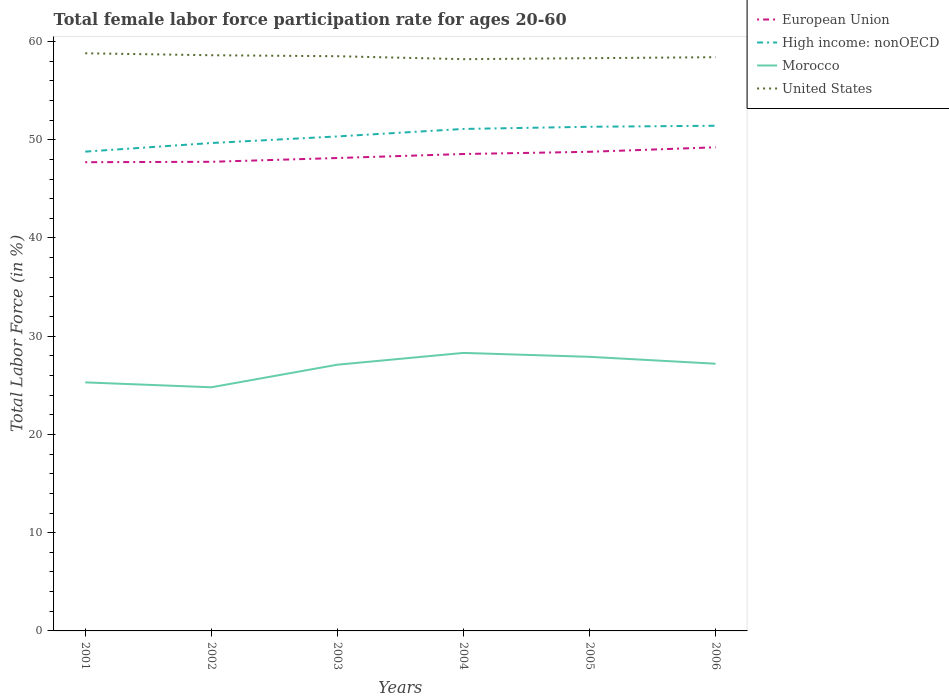How many different coloured lines are there?
Your answer should be very brief. 4. Does the line corresponding to United States intersect with the line corresponding to High income: nonOECD?
Your answer should be compact. No. Across all years, what is the maximum female labor force participation rate in United States?
Make the answer very short. 58.2. In which year was the female labor force participation rate in United States maximum?
Your answer should be very brief. 2004. What is the total female labor force participation rate in European Union in the graph?
Ensure brevity in your answer.  -0.79. What is the difference between the highest and the second highest female labor force participation rate in European Union?
Make the answer very short. 1.52. What is the difference between the highest and the lowest female labor force participation rate in United States?
Your response must be concise. 3. How many lines are there?
Make the answer very short. 4. What is the difference between two consecutive major ticks on the Y-axis?
Your response must be concise. 10. Are the values on the major ticks of Y-axis written in scientific E-notation?
Make the answer very short. No. Does the graph contain any zero values?
Keep it short and to the point. No. Where does the legend appear in the graph?
Ensure brevity in your answer.  Top right. What is the title of the graph?
Give a very brief answer. Total female labor force participation rate for ages 20-60. Does "High income: OECD" appear as one of the legend labels in the graph?
Keep it short and to the point. No. What is the label or title of the X-axis?
Offer a very short reply. Years. What is the label or title of the Y-axis?
Your response must be concise. Total Labor Force (in %). What is the Total Labor Force (in %) of European Union in 2001?
Keep it short and to the point. 47.71. What is the Total Labor Force (in %) of High income: nonOECD in 2001?
Offer a very short reply. 48.79. What is the Total Labor Force (in %) of Morocco in 2001?
Keep it short and to the point. 25.3. What is the Total Labor Force (in %) of United States in 2001?
Offer a terse response. 58.8. What is the Total Labor Force (in %) of European Union in 2002?
Give a very brief answer. 47.75. What is the Total Labor Force (in %) in High income: nonOECD in 2002?
Provide a short and direct response. 49.66. What is the Total Labor Force (in %) of Morocco in 2002?
Make the answer very short. 24.8. What is the Total Labor Force (in %) of United States in 2002?
Offer a very short reply. 58.6. What is the Total Labor Force (in %) of European Union in 2003?
Offer a very short reply. 48.14. What is the Total Labor Force (in %) in High income: nonOECD in 2003?
Provide a short and direct response. 50.34. What is the Total Labor Force (in %) in Morocco in 2003?
Offer a very short reply. 27.1. What is the Total Labor Force (in %) of United States in 2003?
Keep it short and to the point. 58.5. What is the Total Labor Force (in %) in European Union in 2004?
Offer a terse response. 48.55. What is the Total Labor Force (in %) in High income: nonOECD in 2004?
Make the answer very short. 51.1. What is the Total Labor Force (in %) in Morocco in 2004?
Offer a terse response. 28.3. What is the Total Labor Force (in %) in United States in 2004?
Keep it short and to the point. 58.2. What is the Total Labor Force (in %) in European Union in 2005?
Provide a succinct answer. 48.77. What is the Total Labor Force (in %) of High income: nonOECD in 2005?
Ensure brevity in your answer.  51.32. What is the Total Labor Force (in %) in Morocco in 2005?
Provide a short and direct response. 27.9. What is the Total Labor Force (in %) in United States in 2005?
Provide a succinct answer. 58.3. What is the Total Labor Force (in %) of European Union in 2006?
Offer a terse response. 49.23. What is the Total Labor Force (in %) of High income: nonOECD in 2006?
Provide a short and direct response. 51.42. What is the Total Labor Force (in %) in Morocco in 2006?
Your answer should be compact. 27.2. What is the Total Labor Force (in %) in United States in 2006?
Ensure brevity in your answer.  58.4. Across all years, what is the maximum Total Labor Force (in %) of European Union?
Ensure brevity in your answer.  49.23. Across all years, what is the maximum Total Labor Force (in %) of High income: nonOECD?
Ensure brevity in your answer.  51.42. Across all years, what is the maximum Total Labor Force (in %) of Morocco?
Your response must be concise. 28.3. Across all years, what is the maximum Total Labor Force (in %) in United States?
Make the answer very short. 58.8. Across all years, what is the minimum Total Labor Force (in %) in European Union?
Your answer should be very brief. 47.71. Across all years, what is the minimum Total Labor Force (in %) of High income: nonOECD?
Ensure brevity in your answer.  48.79. Across all years, what is the minimum Total Labor Force (in %) in Morocco?
Make the answer very short. 24.8. Across all years, what is the minimum Total Labor Force (in %) of United States?
Your answer should be compact. 58.2. What is the total Total Labor Force (in %) of European Union in the graph?
Offer a terse response. 290.15. What is the total Total Labor Force (in %) of High income: nonOECD in the graph?
Make the answer very short. 302.63. What is the total Total Labor Force (in %) of Morocco in the graph?
Provide a succinct answer. 160.6. What is the total Total Labor Force (in %) in United States in the graph?
Make the answer very short. 350.8. What is the difference between the Total Labor Force (in %) of European Union in 2001 and that in 2002?
Keep it short and to the point. -0.04. What is the difference between the Total Labor Force (in %) of High income: nonOECD in 2001 and that in 2002?
Offer a terse response. -0.87. What is the difference between the Total Labor Force (in %) in United States in 2001 and that in 2002?
Your answer should be compact. 0.2. What is the difference between the Total Labor Force (in %) in European Union in 2001 and that in 2003?
Keep it short and to the point. -0.43. What is the difference between the Total Labor Force (in %) in High income: nonOECD in 2001 and that in 2003?
Offer a very short reply. -1.55. What is the difference between the Total Labor Force (in %) in Morocco in 2001 and that in 2003?
Provide a succinct answer. -1.8. What is the difference between the Total Labor Force (in %) of United States in 2001 and that in 2003?
Your answer should be compact. 0.3. What is the difference between the Total Labor Force (in %) in European Union in 2001 and that in 2004?
Offer a terse response. -0.83. What is the difference between the Total Labor Force (in %) in High income: nonOECD in 2001 and that in 2004?
Offer a very short reply. -2.31. What is the difference between the Total Labor Force (in %) in United States in 2001 and that in 2004?
Offer a very short reply. 0.6. What is the difference between the Total Labor Force (in %) in European Union in 2001 and that in 2005?
Your answer should be very brief. -1.06. What is the difference between the Total Labor Force (in %) in High income: nonOECD in 2001 and that in 2005?
Ensure brevity in your answer.  -2.53. What is the difference between the Total Labor Force (in %) in Morocco in 2001 and that in 2005?
Make the answer very short. -2.6. What is the difference between the Total Labor Force (in %) of United States in 2001 and that in 2005?
Ensure brevity in your answer.  0.5. What is the difference between the Total Labor Force (in %) of European Union in 2001 and that in 2006?
Offer a very short reply. -1.52. What is the difference between the Total Labor Force (in %) of High income: nonOECD in 2001 and that in 2006?
Offer a very short reply. -2.63. What is the difference between the Total Labor Force (in %) in European Union in 2002 and that in 2003?
Give a very brief answer. -0.39. What is the difference between the Total Labor Force (in %) of High income: nonOECD in 2002 and that in 2003?
Provide a succinct answer. -0.67. What is the difference between the Total Labor Force (in %) of European Union in 2002 and that in 2004?
Your answer should be very brief. -0.79. What is the difference between the Total Labor Force (in %) of High income: nonOECD in 2002 and that in 2004?
Your answer should be compact. -1.43. What is the difference between the Total Labor Force (in %) in Morocco in 2002 and that in 2004?
Offer a very short reply. -3.5. What is the difference between the Total Labor Force (in %) in European Union in 2002 and that in 2005?
Keep it short and to the point. -1.02. What is the difference between the Total Labor Force (in %) in High income: nonOECD in 2002 and that in 2005?
Provide a succinct answer. -1.66. What is the difference between the Total Labor Force (in %) in United States in 2002 and that in 2005?
Your answer should be compact. 0.3. What is the difference between the Total Labor Force (in %) in European Union in 2002 and that in 2006?
Offer a terse response. -1.48. What is the difference between the Total Labor Force (in %) in High income: nonOECD in 2002 and that in 2006?
Your response must be concise. -1.76. What is the difference between the Total Labor Force (in %) of European Union in 2003 and that in 2004?
Provide a succinct answer. -0.41. What is the difference between the Total Labor Force (in %) in High income: nonOECD in 2003 and that in 2004?
Make the answer very short. -0.76. What is the difference between the Total Labor Force (in %) of Morocco in 2003 and that in 2004?
Provide a short and direct response. -1.2. What is the difference between the Total Labor Force (in %) in European Union in 2003 and that in 2005?
Make the answer very short. -0.63. What is the difference between the Total Labor Force (in %) of High income: nonOECD in 2003 and that in 2005?
Offer a very short reply. -0.98. What is the difference between the Total Labor Force (in %) in United States in 2003 and that in 2005?
Provide a succinct answer. 0.2. What is the difference between the Total Labor Force (in %) of European Union in 2003 and that in 2006?
Give a very brief answer. -1.09. What is the difference between the Total Labor Force (in %) in High income: nonOECD in 2003 and that in 2006?
Your answer should be compact. -1.09. What is the difference between the Total Labor Force (in %) of United States in 2003 and that in 2006?
Provide a short and direct response. 0.1. What is the difference between the Total Labor Force (in %) in European Union in 2004 and that in 2005?
Ensure brevity in your answer.  -0.22. What is the difference between the Total Labor Force (in %) of High income: nonOECD in 2004 and that in 2005?
Provide a short and direct response. -0.22. What is the difference between the Total Labor Force (in %) of Morocco in 2004 and that in 2005?
Make the answer very short. 0.4. What is the difference between the Total Labor Force (in %) of European Union in 2004 and that in 2006?
Your answer should be very brief. -0.68. What is the difference between the Total Labor Force (in %) in High income: nonOECD in 2004 and that in 2006?
Your answer should be compact. -0.33. What is the difference between the Total Labor Force (in %) of United States in 2004 and that in 2006?
Your answer should be very brief. -0.2. What is the difference between the Total Labor Force (in %) of European Union in 2005 and that in 2006?
Provide a short and direct response. -0.46. What is the difference between the Total Labor Force (in %) in High income: nonOECD in 2005 and that in 2006?
Offer a terse response. -0.1. What is the difference between the Total Labor Force (in %) in United States in 2005 and that in 2006?
Your response must be concise. -0.1. What is the difference between the Total Labor Force (in %) of European Union in 2001 and the Total Labor Force (in %) of High income: nonOECD in 2002?
Your answer should be compact. -1.95. What is the difference between the Total Labor Force (in %) of European Union in 2001 and the Total Labor Force (in %) of Morocco in 2002?
Make the answer very short. 22.91. What is the difference between the Total Labor Force (in %) in European Union in 2001 and the Total Labor Force (in %) in United States in 2002?
Your answer should be very brief. -10.89. What is the difference between the Total Labor Force (in %) in High income: nonOECD in 2001 and the Total Labor Force (in %) in Morocco in 2002?
Ensure brevity in your answer.  23.99. What is the difference between the Total Labor Force (in %) of High income: nonOECD in 2001 and the Total Labor Force (in %) of United States in 2002?
Provide a short and direct response. -9.81. What is the difference between the Total Labor Force (in %) in Morocco in 2001 and the Total Labor Force (in %) in United States in 2002?
Your answer should be very brief. -33.3. What is the difference between the Total Labor Force (in %) of European Union in 2001 and the Total Labor Force (in %) of High income: nonOECD in 2003?
Provide a succinct answer. -2.62. What is the difference between the Total Labor Force (in %) of European Union in 2001 and the Total Labor Force (in %) of Morocco in 2003?
Keep it short and to the point. 20.61. What is the difference between the Total Labor Force (in %) in European Union in 2001 and the Total Labor Force (in %) in United States in 2003?
Make the answer very short. -10.79. What is the difference between the Total Labor Force (in %) in High income: nonOECD in 2001 and the Total Labor Force (in %) in Morocco in 2003?
Offer a very short reply. 21.69. What is the difference between the Total Labor Force (in %) in High income: nonOECD in 2001 and the Total Labor Force (in %) in United States in 2003?
Keep it short and to the point. -9.71. What is the difference between the Total Labor Force (in %) of Morocco in 2001 and the Total Labor Force (in %) of United States in 2003?
Provide a succinct answer. -33.2. What is the difference between the Total Labor Force (in %) in European Union in 2001 and the Total Labor Force (in %) in High income: nonOECD in 2004?
Provide a succinct answer. -3.39. What is the difference between the Total Labor Force (in %) in European Union in 2001 and the Total Labor Force (in %) in Morocco in 2004?
Offer a very short reply. 19.41. What is the difference between the Total Labor Force (in %) of European Union in 2001 and the Total Labor Force (in %) of United States in 2004?
Provide a succinct answer. -10.49. What is the difference between the Total Labor Force (in %) in High income: nonOECD in 2001 and the Total Labor Force (in %) in Morocco in 2004?
Provide a succinct answer. 20.49. What is the difference between the Total Labor Force (in %) of High income: nonOECD in 2001 and the Total Labor Force (in %) of United States in 2004?
Give a very brief answer. -9.41. What is the difference between the Total Labor Force (in %) of Morocco in 2001 and the Total Labor Force (in %) of United States in 2004?
Your answer should be very brief. -32.9. What is the difference between the Total Labor Force (in %) in European Union in 2001 and the Total Labor Force (in %) in High income: nonOECD in 2005?
Your answer should be very brief. -3.61. What is the difference between the Total Labor Force (in %) of European Union in 2001 and the Total Labor Force (in %) of Morocco in 2005?
Your response must be concise. 19.81. What is the difference between the Total Labor Force (in %) of European Union in 2001 and the Total Labor Force (in %) of United States in 2005?
Provide a succinct answer. -10.59. What is the difference between the Total Labor Force (in %) of High income: nonOECD in 2001 and the Total Labor Force (in %) of Morocco in 2005?
Your answer should be very brief. 20.89. What is the difference between the Total Labor Force (in %) in High income: nonOECD in 2001 and the Total Labor Force (in %) in United States in 2005?
Keep it short and to the point. -9.51. What is the difference between the Total Labor Force (in %) of Morocco in 2001 and the Total Labor Force (in %) of United States in 2005?
Your response must be concise. -33. What is the difference between the Total Labor Force (in %) in European Union in 2001 and the Total Labor Force (in %) in High income: nonOECD in 2006?
Give a very brief answer. -3.71. What is the difference between the Total Labor Force (in %) of European Union in 2001 and the Total Labor Force (in %) of Morocco in 2006?
Your answer should be compact. 20.51. What is the difference between the Total Labor Force (in %) in European Union in 2001 and the Total Labor Force (in %) in United States in 2006?
Give a very brief answer. -10.69. What is the difference between the Total Labor Force (in %) in High income: nonOECD in 2001 and the Total Labor Force (in %) in Morocco in 2006?
Provide a succinct answer. 21.59. What is the difference between the Total Labor Force (in %) in High income: nonOECD in 2001 and the Total Labor Force (in %) in United States in 2006?
Make the answer very short. -9.61. What is the difference between the Total Labor Force (in %) of Morocco in 2001 and the Total Labor Force (in %) of United States in 2006?
Provide a succinct answer. -33.1. What is the difference between the Total Labor Force (in %) in European Union in 2002 and the Total Labor Force (in %) in High income: nonOECD in 2003?
Provide a succinct answer. -2.58. What is the difference between the Total Labor Force (in %) of European Union in 2002 and the Total Labor Force (in %) of Morocco in 2003?
Your response must be concise. 20.65. What is the difference between the Total Labor Force (in %) in European Union in 2002 and the Total Labor Force (in %) in United States in 2003?
Give a very brief answer. -10.75. What is the difference between the Total Labor Force (in %) in High income: nonOECD in 2002 and the Total Labor Force (in %) in Morocco in 2003?
Give a very brief answer. 22.56. What is the difference between the Total Labor Force (in %) in High income: nonOECD in 2002 and the Total Labor Force (in %) in United States in 2003?
Make the answer very short. -8.84. What is the difference between the Total Labor Force (in %) of Morocco in 2002 and the Total Labor Force (in %) of United States in 2003?
Provide a succinct answer. -33.7. What is the difference between the Total Labor Force (in %) of European Union in 2002 and the Total Labor Force (in %) of High income: nonOECD in 2004?
Give a very brief answer. -3.34. What is the difference between the Total Labor Force (in %) of European Union in 2002 and the Total Labor Force (in %) of Morocco in 2004?
Your answer should be compact. 19.45. What is the difference between the Total Labor Force (in %) in European Union in 2002 and the Total Labor Force (in %) in United States in 2004?
Provide a short and direct response. -10.45. What is the difference between the Total Labor Force (in %) in High income: nonOECD in 2002 and the Total Labor Force (in %) in Morocco in 2004?
Your response must be concise. 21.36. What is the difference between the Total Labor Force (in %) in High income: nonOECD in 2002 and the Total Labor Force (in %) in United States in 2004?
Offer a terse response. -8.54. What is the difference between the Total Labor Force (in %) in Morocco in 2002 and the Total Labor Force (in %) in United States in 2004?
Keep it short and to the point. -33.4. What is the difference between the Total Labor Force (in %) of European Union in 2002 and the Total Labor Force (in %) of High income: nonOECD in 2005?
Your answer should be compact. -3.57. What is the difference between the Total Labor Force (in %) in European Union in 2002 and the Total Labor Force (in %) in Morocco in 2005?
Your answer should be compact. 19.85. What is the difference between the Total Labor Force (in %) of European Union in 2002 and the Total Labor Force (in %) of United States in 2005?
Make the answer very short. -10.55. What is the difference between the Total Labor Force (in %) in High income: nonOECD in 2002 and the Total Labor Force (in %) in Morocco in 2005?
Ensure brevity in your answer.  21.76. What is the difference between the Total Labor Force (in %) of High income: nonOECD in 2002 and the Total Labor Force (in %) of United States in 2005?
Offer a terse response. -8.64. What is the difference between the Total Labor Force (in %) of Morocco in 2002 and the Total Labor Force (in %) of United States in 2005?
Give a very brief answer. -33.5. What is the difference between the Total Labor Force (in %) in European Union in 2002 and the Total Labor Force (in %) in High income: nonOECD in 2006?
Your response must be concise. -3.67. What is the difference between the Total Labor Force (in %) of European Union in 2002 and the Total Labor Force (in %) of Morocco in 2006?
Your response must be concise. 20.55. What is the difference between the Total Labor Force (in %) of European Union in 2002 and the Total Labor Force (in %) of United States in 2006?
Your answer should be compact. -10.65. What is the difference between the Total Labor Force (in %) of High income: nonOECD in 2002 and the Total Labor Force (in %) of Morocco in 2006?
Offer a terse response. 22.46. What is the difference between the Total Labor Force (in %) of High income: nonOECD in 2002 and the Total Labor Force (in %) of United States in 2006?
Your answer should be compact. -8.74. What is the difference between the Total Labor Force (in %) in Morocco in 2002 and the Total Labor Force (in %) in United States in 2006?
Offer a terse response. -33.6. What is the difference between the Total Labor Force (in %) of European Union in 2003 and the Total Labor Force (in %) of High income: nonOECD in 2004?
Your answer should be very brief. -2.96. What is the difference between the Total Labor Force (in %) of European Union in 2003 and the Total Labor Force (in %) of Morocco in 2004?
Keep it short and to the point. 19.84. What is the difference between the Total Labor Force (in %) in European Union in 2003 and the Total Labor Force (in %) in United States in 2004?
Make the answer very short. -10.06. What is the difference between the Total Labor Force (in %) of High income: nonOECD in 2003 and the Total Labor Force (in %) of Morocco in 2004?
Keep it short and to the point. 22.04. What is the difference between the Total Labor Force (in %) in High income: nonOECD in 2003 and the Total Labor Force (in %) in United States in 2004?
Offer a very short reply. -7.86. What is the difference between the Total Labor Force (in %) in Morocco in 2003 and the Total Labor Force (in %) in United States in 2004?
Ensure brevity in your answer.  -31.1. What is the difference between the Total Labor Force (in %) of European Union in 2003 and the Total Labor Force (in %) of High income: nonOECD in 2005?
Provide a succinct answer. -3.18. What is the difference between the Total Labor Force (in %) of European Union in 2003 and the Total Labor Force (in %) of Morocco in 2005?
Your response must be concise. 20.24. What is the difference between the Total Labor Force (in %) of European Union in 2003 and the Total Labor Force (in %) of United States in 2005?
Provide a succinct answer. -10.16. What is the difference between the Total Labor Force (in %) of High income: nonOECD in 2003 and the Total Labor Force (in %) of Morocco in 2005?
Make the answer very short. 22.44. What is the difference between the Total Labor Force (in %) in High income: nonOECD in 2003 and the Total Labor Force (in %) in United States in 2005?
Give a very brief answer. -7.96. What is the difference between the Total Labor Force (in %) of Morocco in 2003 and the Total Labor Force (in %) of United States in 2005?
Make the answer very short. -31.2. What is the difference between the Total Labor Force (in %) of European Union in 2003 and the Total Labor Force (in %) of High income: nonOECD in 2006?
Give a very brief answer. -3.29. What is the difference between the Total Labor Force (in %) of European Union in 2003 and the Total Labor Force (in %) of Morocco in 2006?
Ensure brevity in your answer.  20.94. What is the difference between the Total Labor Force (in %) of European Union in 2003 and the Total Labor Force (in %) of United States in 2006?
Your answer should be compact. -10.26. What is the difference between the Total Labor Force (in %) in High income: nonOECD in 2003 and the Total Labor Force (in %) in Morocco in 2006?
Offer a terse response. 23.14. What is the difference between the Total Labor Force (in %) of High income: nonOECD in 2003 and the Total Labor Force (in %) of United States in 2006?
Your answer should be very brief. -8.06. What is the difference between the Total Labor Force (in %) of Morocco in 2003 and the Total Labor Force (in %) of United States in 2006?
Give a very brief answer. -31.3. What is the difference between the Total Labor Force (in %) in European Union in 2004 and the Total Labor Force (in %) in High income: nonOECD in 2005?
Ensure brevity in your answer.  -2.77. What is the difference between the Total Labor Force (in %) in European Union in 2004 and the Total Labor Force (in %) in Morocco in 2005?
Make the answer very short. 20.65. What is the difference between the Total Labor Force (in %) of European Union in 2004 and the Total Labor Force (in %) of United States in 2005?
Provide a succinct answer. -9.75. What is the difference between the Total Labor Force (in %) in High income: nonOECD in 2004 and the Total Labor Force (in %) in Morocco in 2005?
Your answer should be compact. 23.2. What is the difference between the Total Labor Force (in %) of High income: nonOECD in 2004 and the Total Labor Force (in %) of United States in 2005?
Ensure brevity in your answer.  -7.2. What is the difference between the Total Labor Force (in %) in European Union in 2004 and the Total Labor Force (in %) in High income: nonOECD in 2006?
Your response must be concise. -2.88. What is the difference between the Total Labor Force (in %) of European Union in 2004 and the Total Labor Force (in %) of Morocco in 2006?
Provide a succinct answer. 21.35. What is the difference between the Total Labor Force (in %) of European Union in 2004 and the Total Labor Force (in %) of United States in 2006?
Your response must be concise. -9.85. What is the difference between the Total Labor Force (in %) of High income: nonOECD in 2004 and the Total Labor Force (in %) of Morocco in 2006?
Offer a very short reply. 23.9. What is the difference between the Total Labor Force (in %) in High income: nonOECD in 2004 and the Total Labor Force (in %) in United States in 2006?
Provide a short and direct response. -7.3. What is the difference between the Total Labor Force (in %) in Morocco in 2004 and the Total Labor Force (in %) in United States in 2006?
Make the answer very short. -30.1. What is the difference between the Total Labor Force (in %) of European Union in 2005 and the Total Labor Force (in %) of High income: nonOECD in 2006?
Your answer should be very brief. -2.65. What is the difference between the Total Labor Force (in %) of European Union in 2005 and the Total Labor Force (in %) of Morocco in 2006?
Make the answer very short. 21.57. What is the difference between the Total Labor Force (in %) in European Union in 2005 and the Total Labor Force (in %) in United States in 2006?
Provide a succinct answer. -9.63. What is the difference between the Total Labor Force (in %) in High income: nonOECD in 2005 and the Total Labor Force (in %) in Morocco in 2006?
Your answer should be compact. 24.12. What is the difference between the Total Labor Force (in %) in High income: nonOECD in 2005 and the Total Labor Force (in %) in United States in 2006?
Provide a succinct answer. -7.08. What is the difference between the Total Labor Force (in %) of Morocco in 2005 and the Total Labor Force (in %) of United States in 2006?
Make the answer very short. -30.5. What is the average Total Labor Force (in %) of European Union per year?
Offer a terse response. 48.36. What is the average Total Labor Force (in %) of High income: nonOECD per year?
Your answer should be compact. 50.44. What is the average Total Labor Force (in %) of Morocco per year?
Keep it short and to the point. 26.77. What is the average Total Labor Force (in %) in United States per year?
Offer a very short reply. 58.47. In the year 2001, what is the difference between the Total Labor Force (in %) of European Union and Total Labor Force (in %) of High income: nonOECD?
Give a very brief answer. -1.08. In the year 2001, what is the difference between the Total Labor Force (in %) in European Union and Total Labor Force (in %) in Morocco?
Offer a very short reply. 22.41. In the year 2001, what is the difference between the Total Labor Force (in %) in European Union and Total Labor Force (in %) in United States?
Offer a very short reply. -11.09. In the year 2001, what is the difference between the Total Labor Force (in %) of High income: nonOECD and Total Labor Force (in %) of Morocco?
Your answer should be compact. 23.49. In the year 2001, what is the difference between the Total Labor Force (in %) of High income: nonOECD and Total Labor Force (in %) of United States?
Give a very brief answer. -10.01. In the year 2001, what is the difference between the Total Labor Force (in %) of Morocco and Total Labor Force (in %) of United States?
Provide a succinct answer. -33.5. In the year 2002, what is the difference between the Total Labor Force (in %) of European Union and Total Labor Force (in %) of High income: nonOECD?
Keep it short and to the point. -1.91. In the year 2002, what is the difference between the Total Labor Force (in %) of European Union and Total Labor Force (in %) of Morocco?
Offer a terse response. 22.95. In the year 2002, what is the difference between the Total Labor Force (in %) of European Union and Total Labor Force (in %) of United States?
Ensure brevity in your answer.  -10.85. In the year 2002, what is the difference between the Total Labor Force (in %) in High income: nonOECD and Total Labor Force (in %) in Morocco?
Offer a very short reply. 24.86. In the year 2002, what is the difference between the Total Labor Force (in %) in High income: nonOECD and Total Labor Force (in %) in United States?
Keep it short and to the point. -8.94. In the year 2002, what is the difference between the Total Labor Force (in %) of Morocco and Total Labor Force (in %) of United States?
Give a very brief answer. -33.8. In the year 2003, what is the difference between the Total Labor Force (in %) in European Union and Total Labor Force (in %) in High income: nonOECD?
Your answer should be very brief. -2.2. In the year 2003, what is the difference between the Total Labor Force (in %) in European Union and Total Labor Force (in %) in Morocco?
Your response must be concise. 21.04. In the year 2003, what is the difference between the Total Labor Force (in %) in European Union and Total Labor Force (in %) in United States?
Make the answer very short. -10.36. In the year 2003, what is the difference between the Total Labor Force (in %) in High income: nonOECD and Total Labor Force (in %) in Morocco?
Provide a succinct answer. 23.24. In the year 2003, what is the difference between the Total Labor Force (in %) of High income: nonOECD and Total Labor Force (in %) of United States?
Your answer should be very brief. -8.16. In the year 2003, what is the difference between the Total Labor Force (in %) of Morocco and Total Labor Force (in %) of United States?
Provide a succinct answer. -31.4. In the year 2004, what is the difference between the Total Labor Force (in %) in European Union and Total Labor Force (in %) in High income: nonOECD?
Provide a succinct answer. -2.55. In the year 2004, what is the difference between the Total Labor Force (in %) in European Union and Total Labor Force (in %) in Morocco?
Provide a succinct answer. 20.25. In the year 2004, what is the difference between the Total Labor Force (in %) in European Union and Total Labor Force (in %) in United States?
Offer a very short reply. -9.65. In the year 2004, what is the difference between the Total Labor Force (in %) in High income: nonOECD and Total Labor Force (in %) in Morocco?
Offer a terse response. 22.8. In the year 2004, what is the difference between the Total Labor Force (in %) of High income: nonOECD and Total Labor Force (in %) of United States?
Your answer should be compact. -7.1. In the year 2004, what is the difference between the Total Labor Force (in %) in Morocco and Total Labor Force (in %) in United States?
Give a very brief answer. -29.9. In the year 2005, what is the difference between the Total Labor Force (in %) of European Union and Total Labor Force (in %) of High income: nonOECD?
Provide a succinct answer. -2.55. In the year 2005, what is the difference between the Total Labor Force (in %) of European Union and Total Labor Force (in %) of Morocco?
Your answer should be very brief. 20.87. In the year 2005, what is the difference between the Total Labor Force (in %) of European Union and Total Labor Force (in %) of United States?
Keep it short and to the point. -9.53. In the year 2005, what is the difference between the Total Labor Force (in %) in High income: nonOECD and Total Labor Force (in %) in Morocco?
Your response must be concise. 23.42. In the year 2005, what is the difference between the Total Labor Force (in %) in High income: nonOECD and Total Labor Force (in %) in United States?
Keep it short and to the point. -6.98. In the year 2005, what is the difference between the Total Labor Force (in %) of Morocco and Total Labor Force (in %) of United States?
Offer a very short reply. -30.4. In the year 2006, what is the difference between the Total Labor Force (in %) in European Union and Total Labor Force (in %) in High income: nonOECD?
Give a very brief answer. -2.19. In the year 2006, what is the difference between the Total Labor Force (in %) in European Union and Total Labor Force (in %) in Morocco?
Your answer should be very brief. 22.03. In the year 2006, what is the difference between the Total Labor Force (in %) in European Union and Total Labor Force (in %) in United States?
Give a very brief answer. -9.17. In the year 2006, what is the difference between the Total Labor Force (in %) in High income: nonOECD and Total Labor Force (in %) in Morocco?
Keep it short and to the point. 24.22. In the year 2006, what is the difference between the Total Labor Force (in %) in High income: nonOECD and Total Labor Force (in %) in United States?
Provide a short and direct response. -6.98. In the year 2006, what is the difference between the Total Labor Force (in %) of Morocco and Total Labor Force (in %) of United States?
Provide a short and direct response. -31.2. What is the ratio of the Total Labor Force (in %) of High income: nonOECD in 2001 to that in 2002?
Ensure brevity in your answer.  0.98. What is the ratio of the Total Labor Force (in %) of Morocco in 2001 to that in 2002?
Offer a terse response. 1.02. What is the ratio of the Total Labor Force (in %) of United States in 2001 to that in 2002?
Your answer should be compact. 1. What is the ratio of the Total Labor Force (in %) in European Union in 2001 to that in 2003?
Your answer should be very brief. 0.99. What is the ratio of the Total Labor Force (in %) in High income: nonOECD in 2001 to that in 2003?
Give a very brief answer. 0.97. What is the ratio of the Total Labor Force (in %) of Morocco in 2001 to that in 2003?
Provide a succinct answer. 0.93. What is the ratio of the Total Labor Force (in %) in United States in 2001 to that in 2003?
Your answer should be compact. 1.01. What is the ratio of the Total Labor Force (in %) in European Union in 2001 to that in 2004?
Provide a succinct answer. 0.98. What is the ratio of the Total Labor Force (in %) in High income: nonOECD in 2001 to that in 2004?
Offer a very short reply. 0.95. What is the ratio of the Total Labor Force (in %) in Morocco in 2001 to that in 2004?
Offer a terse response. 0.89. What is the ratio of the Total Labor Force (in %) of United States in 2001 to that in 2004?
Your answer should be compact. 1.01. What is the ratio of the Total Labor Force (in %) of European Union in 2001 to that in 2005?
Give a very brief answer. 0.98. What is the ratio of the Total Labor Force (in %) of High income: nonOECD in 2001 to that in 2005?
Your response must be concise. 0.95. What is the ratio of the Total Labor Force (in %) of Morocco in 2001 to that in 2005?
Your answer should be very brief. 0.91. What is the ratio of the Total Labor Force (in %) of United States in 2001 to that in 2005?
Offer a terse response. 1.01. What is the ratio of the Total Labor Force (in %) in European Union in 2001 to that in 2006?
Provide a short and direct response. 0.97. What is the ratio of the Total Labor Force (in %) in High income: nonOECD in 2001 to that in 2006?
Give a very brief answer. 0.95. What is the ratio of the Total Labor Force (in %) in Morocco in 2001 to that in 2006?
Provide a short and direct response. 0.93. What is the ratio of the Total Labor Force (in %) in United States in 2001 to that in 2006?
Give a very brief answer. 1.01. What is the ratio of the Total Labor Force (in %) of High income: nonOECD in 2002 to that in 2003?
Give a very brief answer. 0.99. What is the ratio of the Total Labor Force (in %) in Morocco in 2002 to that in 2003?
Your answer should be compact. 0.92. What is the ratio of the Total Labor Force (in %) in European Union in 2002 to that in 2004?
Provide a succinct answer. 0.98. What is the ratio of the Total Labor Force (in %) of High income: nonOECD in 2002 to that in 2004?
Offer a terse response. 0.97. What is the ratio of the Total Labor Force (in %) in Morocco in 2002 to that in 2004?
Ensure brevity in your answer.  0.88. What is the ratio of the Total Labor Force (in %) in United States in 2002 to that in 2004?
Your answer should be compact. 1.01. What is the ratio of the Total Labor Force (in %) of European Union in 2002 to that in 2005?
Provide a succinct answer. 0.98. What is the ratio of the Total Labor Force (in %) in High income: nonOECD in 2002 to that in 2005?
Make the answer very short. 0.97. What is the ratio of the Total Labor Force (in %) in Morocco in 2002 to that in 2005?
Give a very brief answer. 0.89. What is the ratio of the Total Labor Force (in %) of United States in 2002 to that in 2005?
Your answer should be compact. 1.01. What is the ratio of the Total Labor Force (in %) in European Union in 2002 to that in 2006?
Give a very brief answer. 0.97. What is the ratio of the Total Labor Force (in %) in High income: nonOECD in 2002 to that in 2006?
Offer a terse response. 0.97. What is the ratio of the Total Labor Force (in %) in Morocco in 2002 to that in 2006?
Offer a terse response. 0.91. What is the ratio of the Total Labor Force (in %) of High income: nonOECD in 2003 to that in 2004?
Your response must be concise. 0.99. What is the ratio of the Total Labor Force (in %) of Morocco in 2003 to that in 2004?
Keep it short and to the point. 0.96. What is the ratio of the Total Labor Force (in %) in High income: nonOECD in 2003 to that in 2005?
Offer a very short reply. 0.98. What is the ratio of the Total Labor Force (in %) of Morocco in 2003 to that in 2005?
Offer a terse response. 0.97. What is the ratio of the Total Labor Force (in %) in United States in 2003 to that in 2005?
Your response must be concise. 1. What is the ratio of the Total Labor Force (in %) of European Union in 2003 to that in 2006?
Make the answer very short. 0.98. What is the ratio of the Total Labor Force (in %) of High income: nonOECD in 2003 to that in 2006?
Give a very brief answer. 0.98. What is the ratio of the Total Labor Force (in %) of European Union in 2004 to that in 2005?
Provide a short and direct response. 1. What is the ratio of the Total Labor Force (in %) of Morocco in 2004 to that in 2005?
Provide a short and direct response. 1.01. What is the ratio of the Total Labor Force (in %) in United States in 2004 to that in 2005?
Provide a succinct answer. 1. What is the ratio of the Total Labor Force (in %) of European Union in 2004 to that in 2006?
Provide a short and direct response. 0.99. What is the ratio of the Total Labor Force (in %) of Morocco in 2004 to that in 2006?
Offer a terse response. 1.04. What is the ratio of the Total Labor Force (in %) of United States in 2004 to that in 2006?
Offer a very short reply. 1. What is the ratio of the Total Labor Force (in %) in European Union in 2005 to that in 2006?
Provide a short and direct response. 0.99. What is the ratio of the Total Labor Force (in %) of High income: nonOECD in 2005 to that in 2006?
Keep it short and to the point. 1. What is the ratio of the Total Labor Force (in %) of Morocco in 2005 to that in 2006?
Provide a short and direct response. 1.03. What is the difference between the highest and the second highest Total Labor Force (in %) in European Union?
Your answer should be very brief. 0.46. What is the difference between the highest and the second highest Total Labor Force (in %) of High income: nonOECD?
Offer a terse response. 0.1. What is the difference between the highest and the second highest Total Labor Force (in %) in United States?
Make the answer very short. 0.2. What is the difference between the highest and the lowest Total Labor Force (in %) of European Union?
Provide a short and direct response. 1.52. What is the difference between the highest and the lowest Total Labor Force (in %) in High income: nonOECD?
Give a very brief answer. 2.63. What is the difference between the highest and the lowest Total Labor Force (in %) in United States?
Your response must be concise. 0.6. 